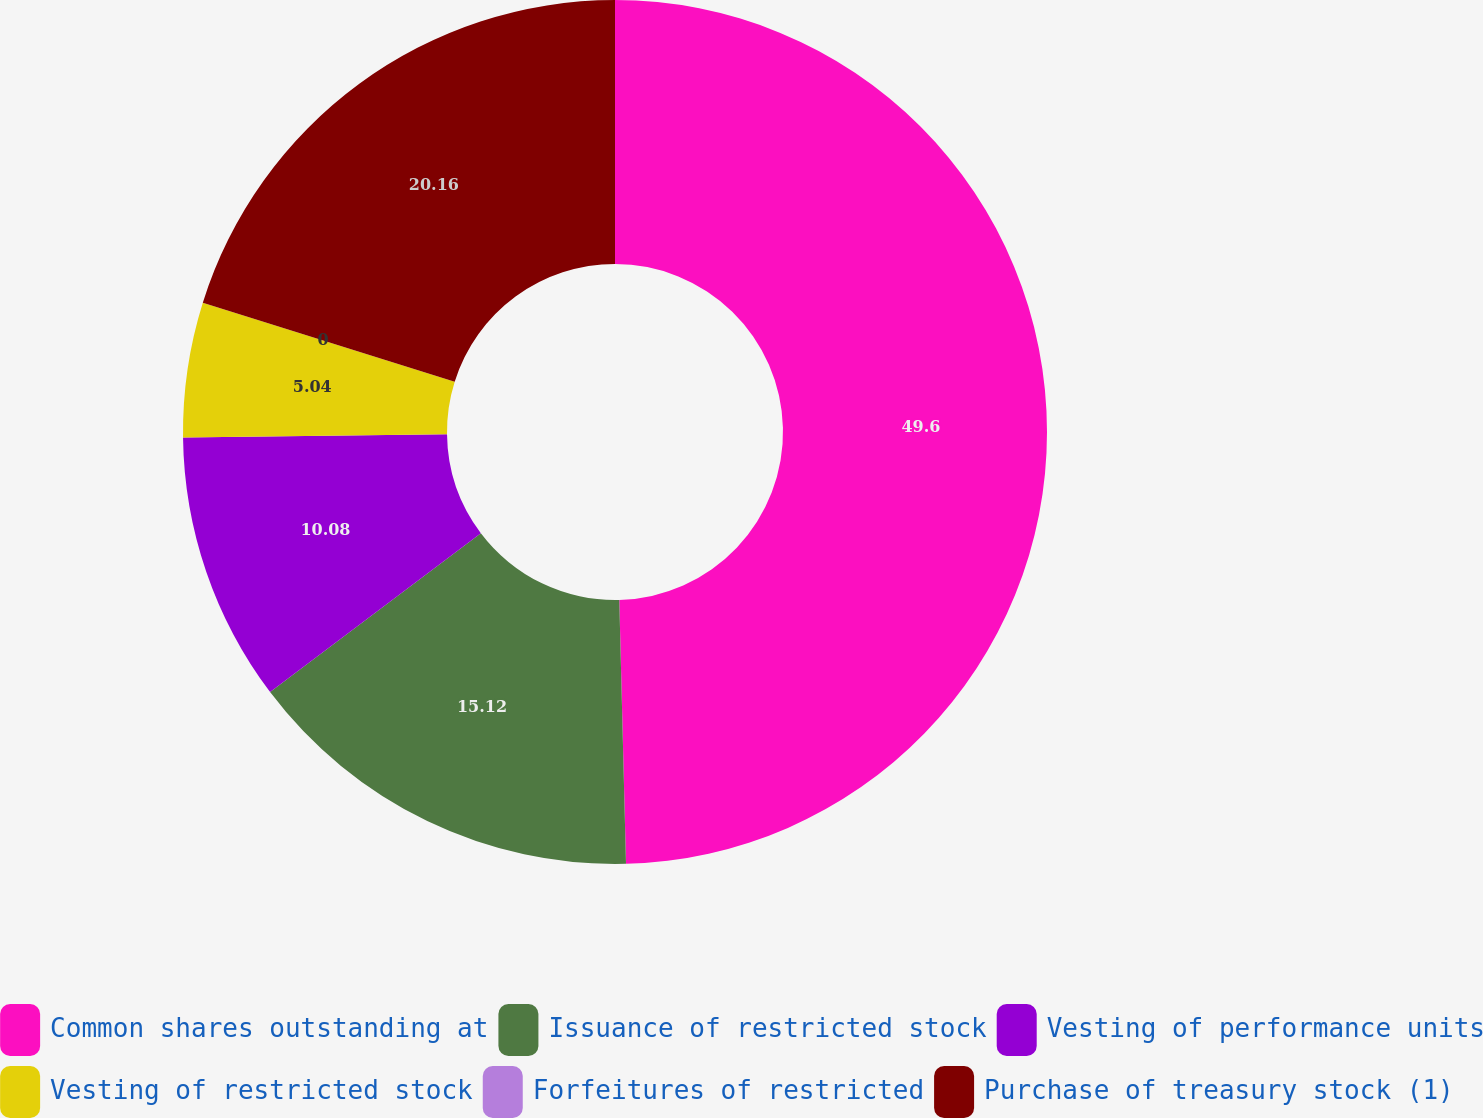Convert chart to OTSL. <chart><loc_0><loc_0><loc_500><loc_500><pie_chart><fcel>Common shares outstanding at<fcel>Issuance of restricted stock<fcel>Vesting of performance units<fcel>Vesting of restricted stock<fcel>Forfeitures of restricted<fcel>Purchase of treasury stock (1)<nl><fcel>49.59%<fcel>15.12%<fcel>10.08%<fcel>5.04%<fcel>0.0%<fcel>20.16%<nl></chart> 